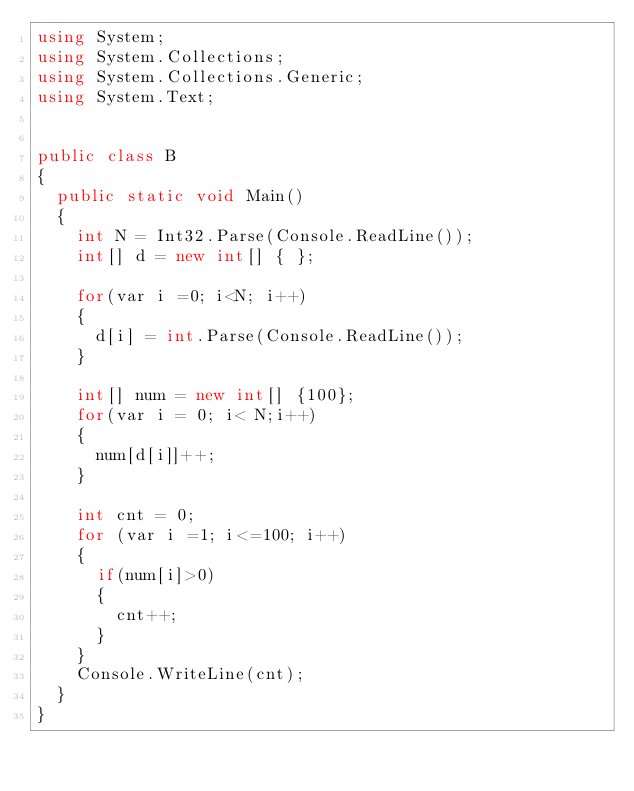Convert code to text. <code><loc_0><loc_0><loc_500><loc_500><_C#_>using System;
using System.Collections;
using System.Collections.Generic;
using System.Text;


public class B
{
	public static void Main()
	{
		int N = Int32.Parse(Console.ReadLine());
		int[] d = new int[] { };

		for(var i =0; i<N; i++)
		{
			d[i] = int.Parse(Console.ReadLine());
		}

		int[] num = new int[] {100};
		for(var i = 0; i< N;i++)
		{
			num[d[i]]++;
		}

		int cnt = 0;
		for (var i =1; i<=100; i++)
		{
			if(num[i]>0)
			{
				cnt++;
			}
		}
		Console.WriteLine(cnt);
	}
}



</code> 